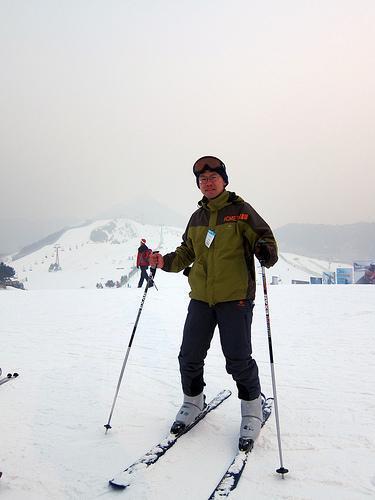How many people are shown?
Give a very brief answer. 2. 